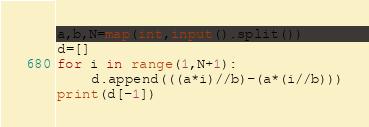Convert code to text. <code><loc_0><loc_0><loc_500><loc_500><_Python_>a,b,N=map(int,input().split())
d=[]
for i in range(1,N+1):
    d.append(((a*i)//b)-(a*(i//b)))
print(d[-1])</code> 